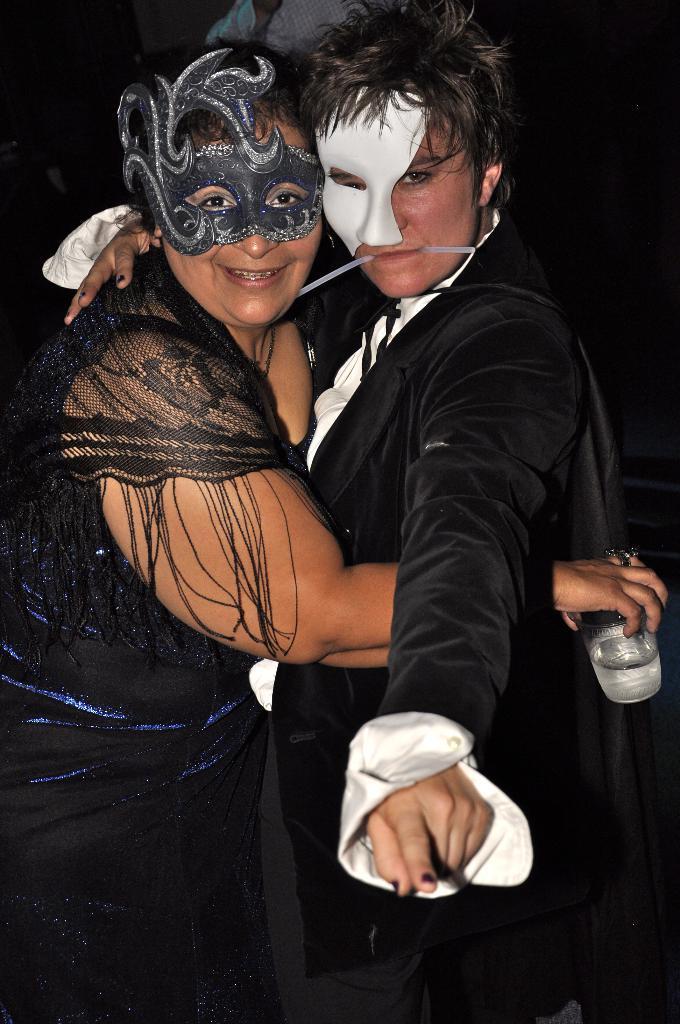Please provide a concise description of this image. In the image there is a lady with a mask on her face is standing and she is holding a glass in her hand. In front of her there is a person with a mask on the face. And there is a black background. 